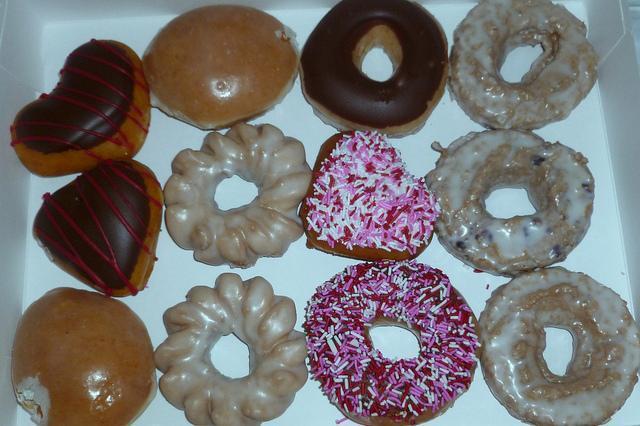How many of the dozen donuts could be cream-filled?
Pick the correct solution from the four options below to address the question.
Options: Three, seven, five, two. Five. 